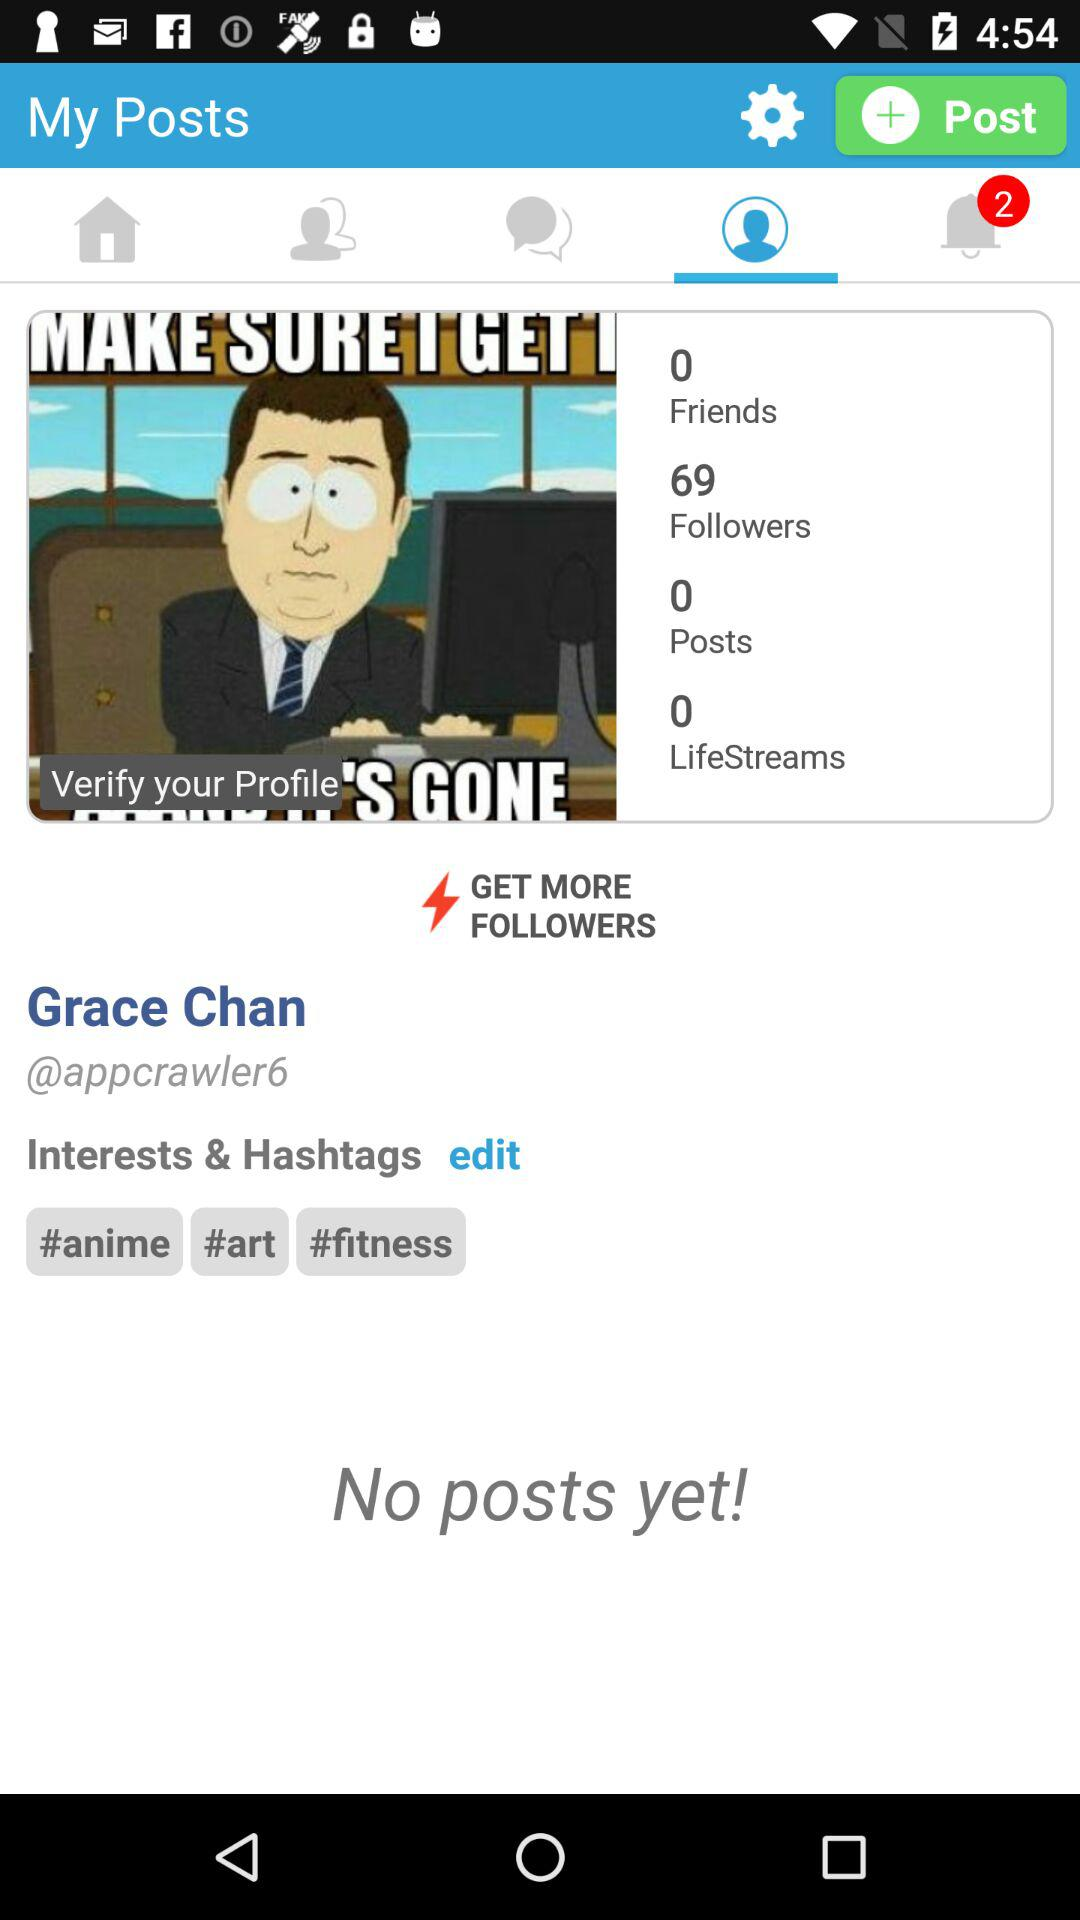What is the name of the user? The name of the user is Grace Chan. 